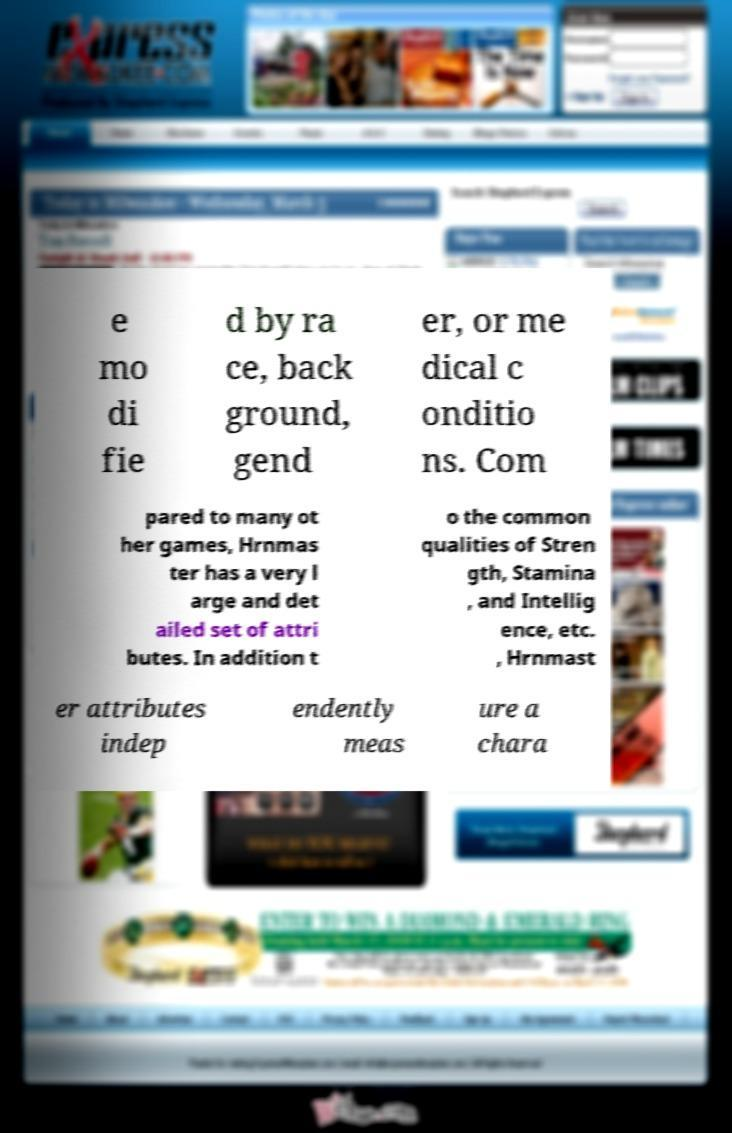Could you extract and type out the text from this image? e mo di fie d by ra ce, back ground, gend er, or me dical c onditio ns. Com pared to many ot her games, Hrnmas ter has a very l arge and det ailed set of attri butes. In addition t o the common qualities of Stren gth, Stamina , and Intellig ence, etc. , Hrnmast er attributes indep endently meas ure a chara 